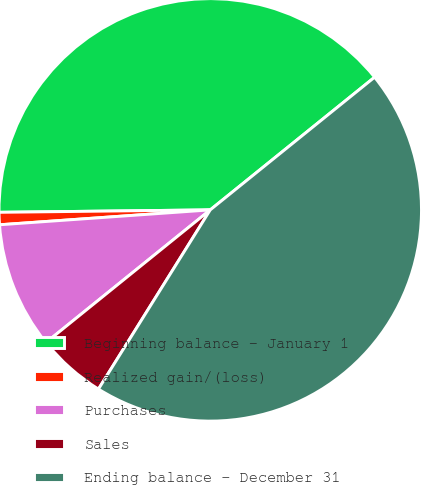Convert chart to OTSL. <chart><loc_0><loc_0><loc_500><loc_500><pie_chart><fcel>Beginning balance - January 1<fcel>Realized gain/(loss)<fcel>Purchases<fcel>Sales<fcel>Ending balance - December 31<nl><fcel>39.38%<fcel>0.94%<fcel>9.69%<fcel>5.31%<fcel>44.69%<nl></chart> 